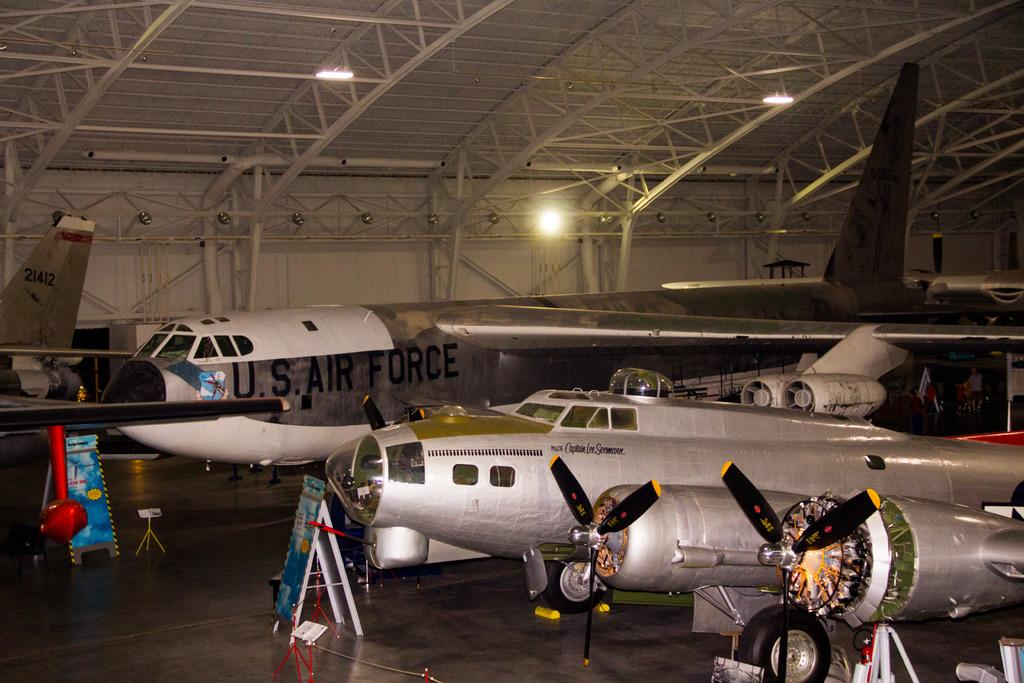<image>
Render a clear and concise summary of the photo. inside the building are many airplanes, including a US air force one 